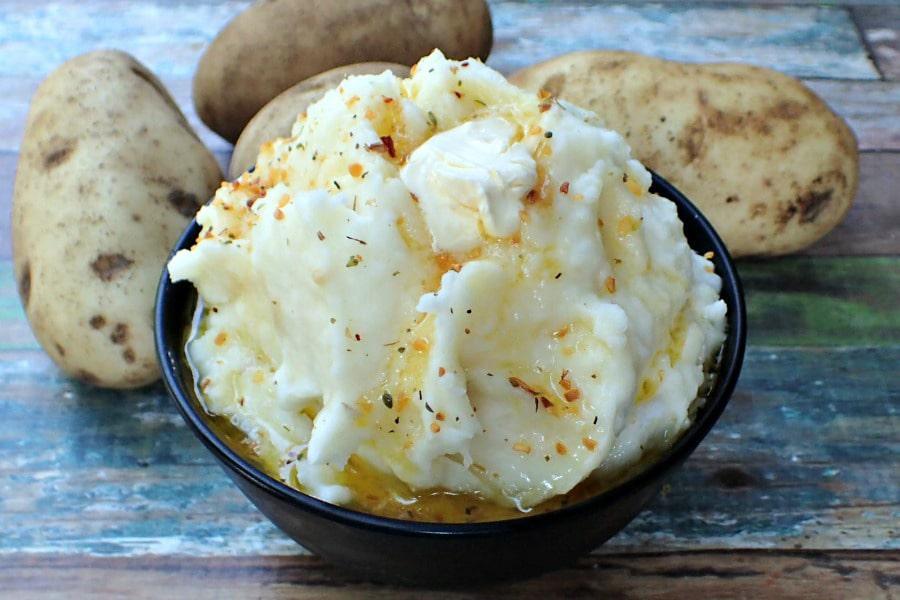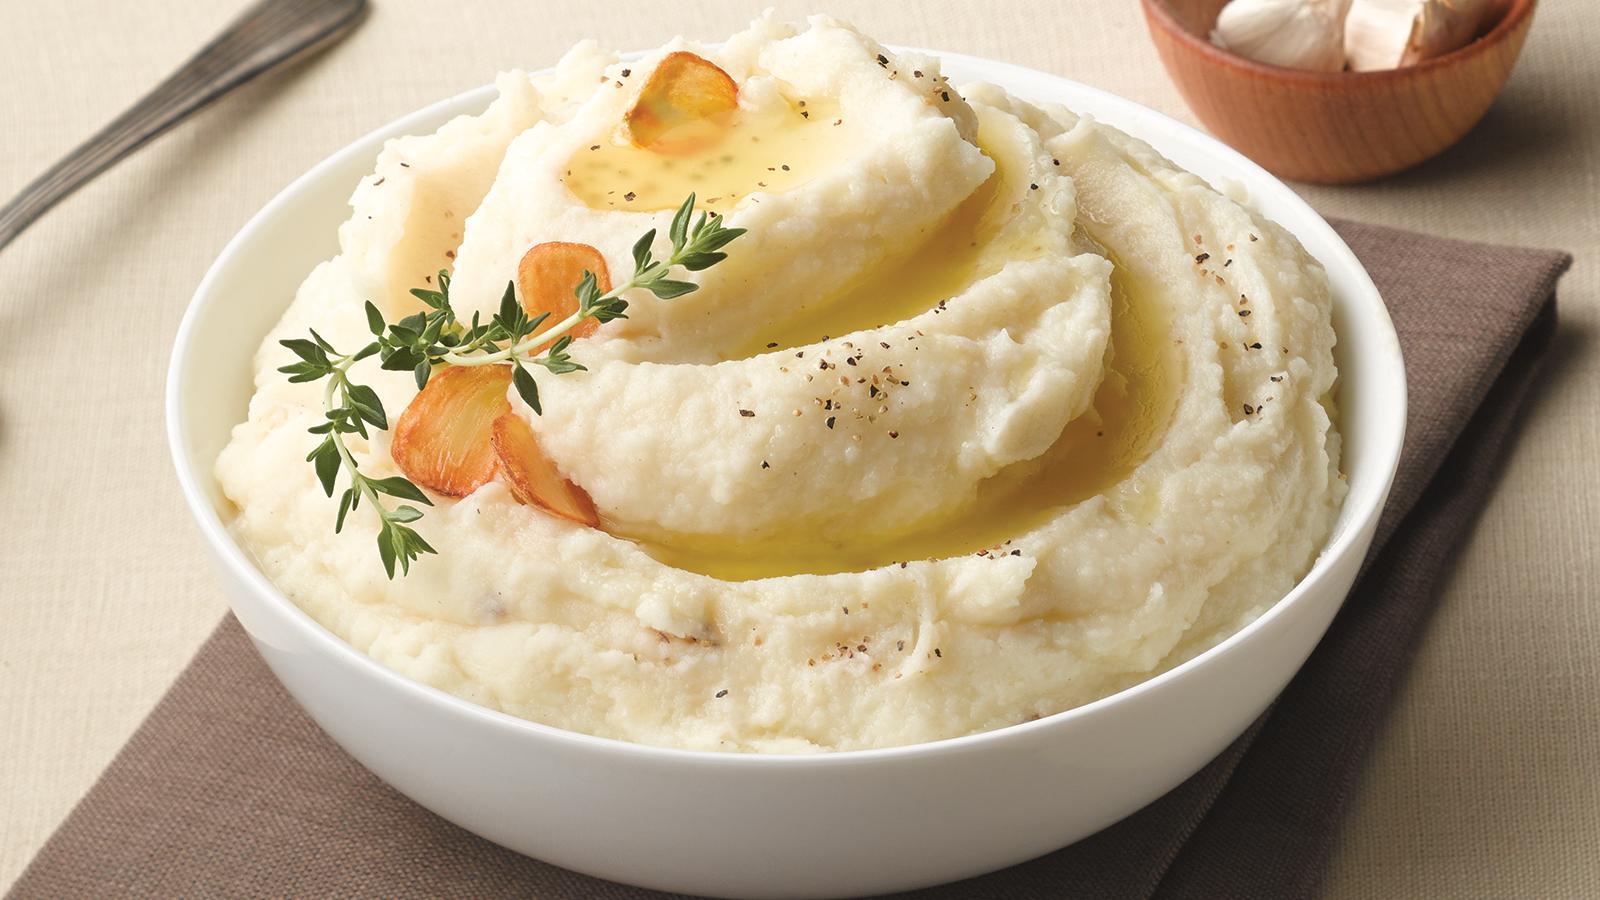The first image is the image on the left, the second image is the image on the right. Assess this claim about the two images: "Cloves of garlic are above one of the bowls of mashed potatoes.". Correct or not? Answer yes or no. Yes. The first image is the image on the left, the second image is the image on the right. Evaluate the accuracy of this statement regarding the images: "The left image shows finely chopped green herbs sprinkled across the top of the mashed potatoes.". Is it true? Answer yes or no. No. 